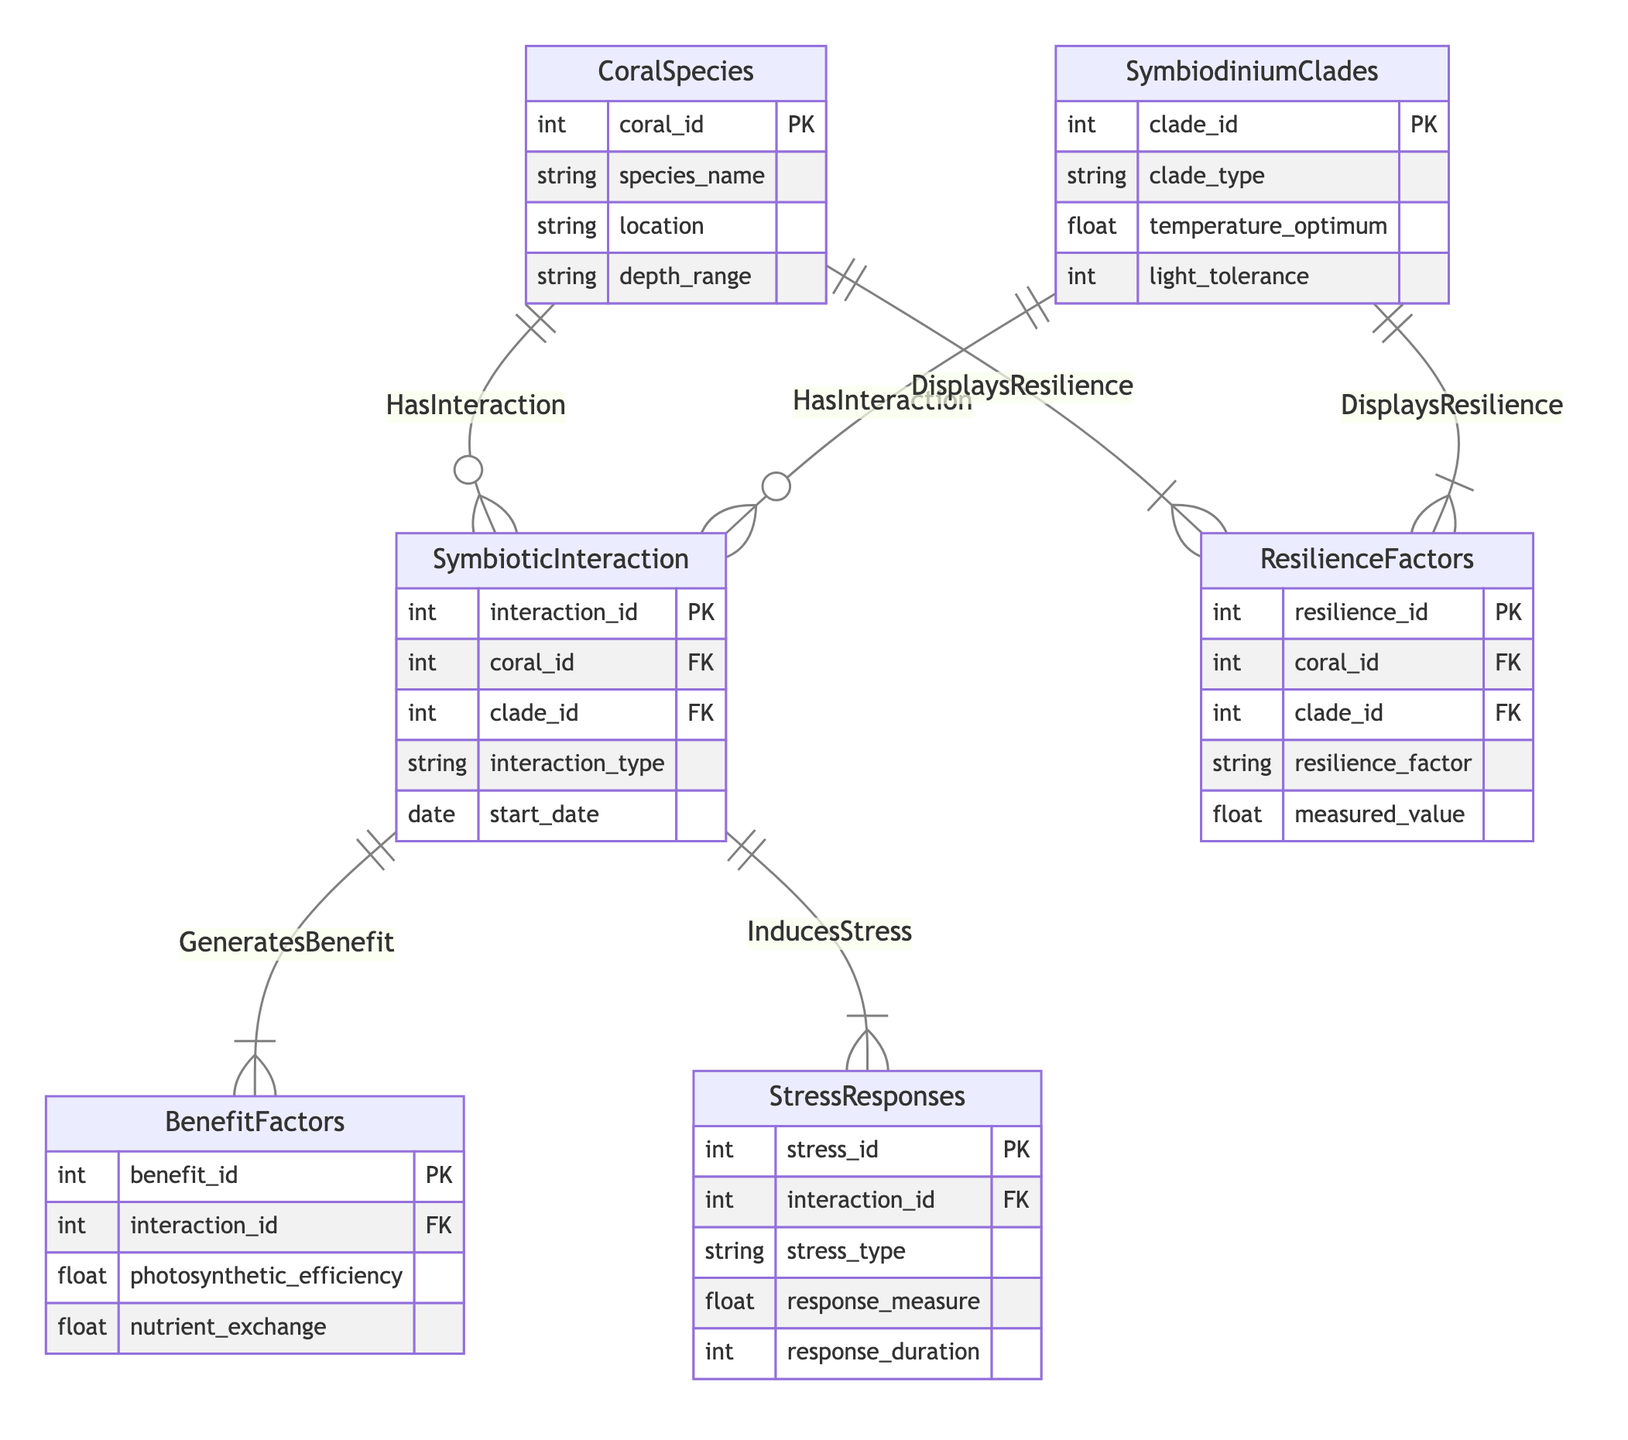What entities are present in the diagram? The diagram includes six entities: CoralSpecies, SymbiodiniumClades, SymbioticInteraction, BenefitFactors, StressResponses, and ResilienceFactors. Each entity represents a different aspect of the study on coral and algae interactions.
Answer: CoralSpecies, SymbiodiniumClades, SymbioticInteraction, BenefitFactors, StressResponses, ResilienceFactors How many relationships are depicted in the diagram? There are five relationships shown in the diagram: HasInteraction (between CoralSpecies and SymbiodiniumClades), GeneratesBenefit (between SymbioticInteraction and BenefitFactors), InducesStress (between SymbioticInteraction and StressResponses), and DisplaysResilience (between CoralSpecies and ResilienceFactors as well as between SymbiodiniumClades and ResilienceFactors). Adding these gives a total of five relationships.
Answer: 5 What is the cardinality between CoralSpecies and SymbiodiniumClades? The relationship between CoralSpecies and SymbiodiniumClades is many-to-many, indicating that each coral species can interact with multiple clades and vice versa. This is explicitly labeled in the relationship called HasInteraction.
Answer: many-to-many Which entity generates benefits? The entity SymbioticInteraction is the one that generates benefits, as indicated by the relationship GeneratesBenefit connecting it to BenefitFactors. This implies that benefits are tied to specific interactions.
Answer: SymbioticInteraction How many attributes does the SymbiodiniumClades entity have? The SymbiodiniumClades entity contains four attributes: clade_id, clade_type, temperature_optimum, and light_tolerance. Counting these attributes gives us a total of four.
Answer: 4 Which relationship connects StressResponses to SymbioticInteraction? The relationship that connects StressResponses to SymbioticInteraction is named InducesStress. This indicates that specific interactions can induce stress responses within the coral-algae symbiotic relationship.
Answer: InducesStress What types of resilience factors are associated with CoralSpecies? The resilience factors associated with CoralSpecies are determined by the ResilienceFactors entity, which is connected through the relationship DisplaysResilience. It indicates that CoralSpecies has multiple types of associated resilience factors.
Answer: ResilienceFactors What kind of interaction type can be found in the SymbioticInteraction entity? The interaction_type attribute in the SymbioticInteraction entity describes the nature of interactions between coral species and Symbiodinium clades. This attribute allows for various types of interactions to be documented.
Answer: interaction_type How many different stress types can be recorded for an interaction? The StressResponses entity features the attribute stress_type, indicating multiple types of stress can be documented per interaction. Thus, there can be various stress types noted for each interaction, which correlates with the one-to-many relationship involving StressResponses.
Answer: multiple 